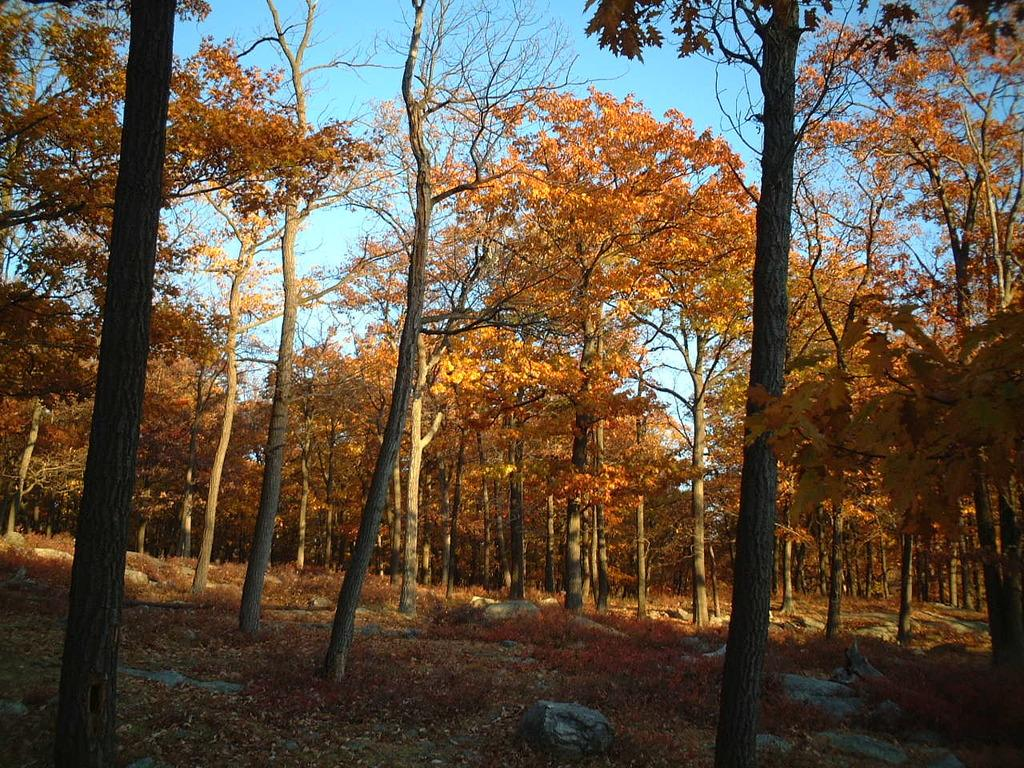What type of vegetation can be seen in the image? There are trees with branches and leaves in the image. What other natural elements are visible in the image? There are rocks visible in the image. Is there any indication of a ground cover in the image? Yes, there appears to be grass in the image. How much income do the trees generate in the image? There is no information about the income generated by the trees in the image. Trees do not generate income in the way humans do. 